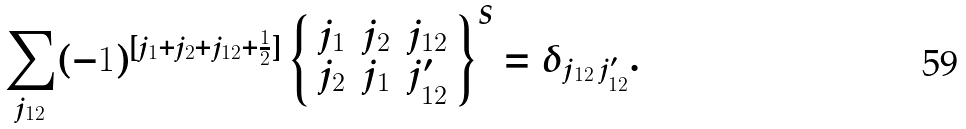<formula> <loc_0><loc_0><loc_500><loc_500>\sum _ { j _ { 1 2 } } ( - 1 ) ^ { [ j _ { 1 } + j _ { 2 } + j _ { 1 2 } + \frac { 1 } { 2 } ] } \left \{ \begin{array} { c c c } j _ { 1 } & j _ { 2 } & j _ { 1 2 } \\ j _ { 2 } & j _ { 1 } & j ^ { \prime } _ { 1 2 } \end{array} \right \} ^ { S } = \delta _ { j _ { 1 2 } \, j ^ { \prime } _ { 1 2 } } .</formula> 